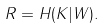<formula> <loc_0><loc_0><loc_500><loc_500>R = H ( K | W ) .</formula> 